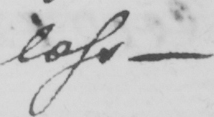Can you read and transcribe this handwriting? less  _ 